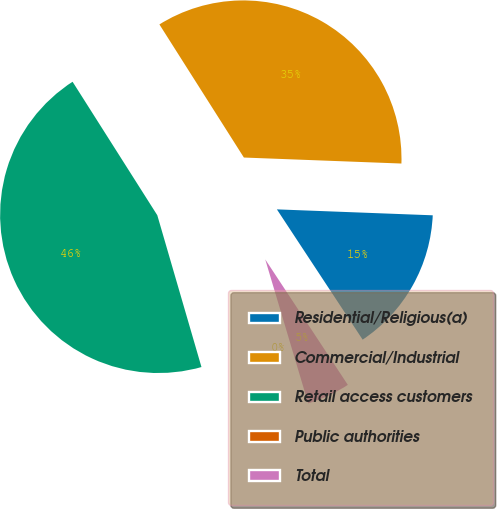Convert chart. <chart><loc_0><loc_0><loc_500><loc_500><pie_chart><fcel>Residential/Religious(a)<fcel>Commercial/Industrial<fcel>Retail access customers<fcel>Public authorities<fcel>Total<nl><fcel>15.13%<fcel>34.61%<fcel>45.51%<fcel>0.11%<fcel>4.65%<nl></chart> 